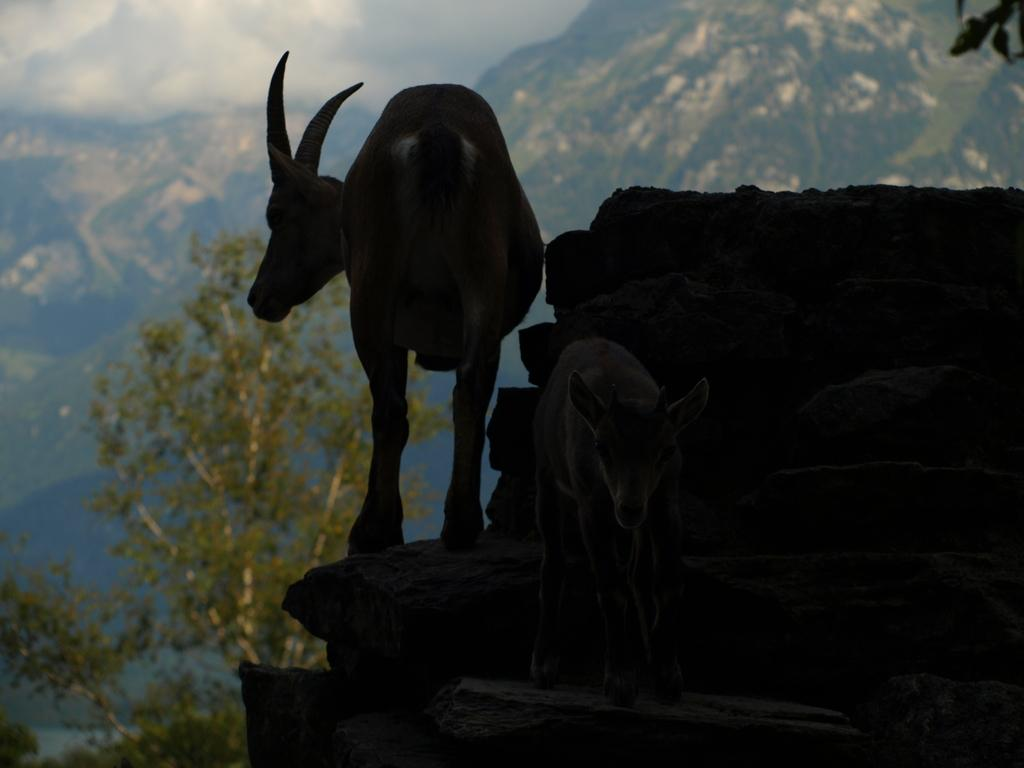What can be found in the center of the image? There are two animals in the center of the image. What is located on the right side of the image? There is a wall on the right side of the image. What can be seen in the background of the image? There are mountains and trees in the background of the image. What is visible at the top of the image? The sky is visible at the top of the image, and clouds are present in the sky. How many snails are crawling on the seashore in the image? There is no seashore or snails present in the image. What type of deer can be seen grazing near the wall in the image? There are no deer present in the image; it features two animals, but their species is not specified. 